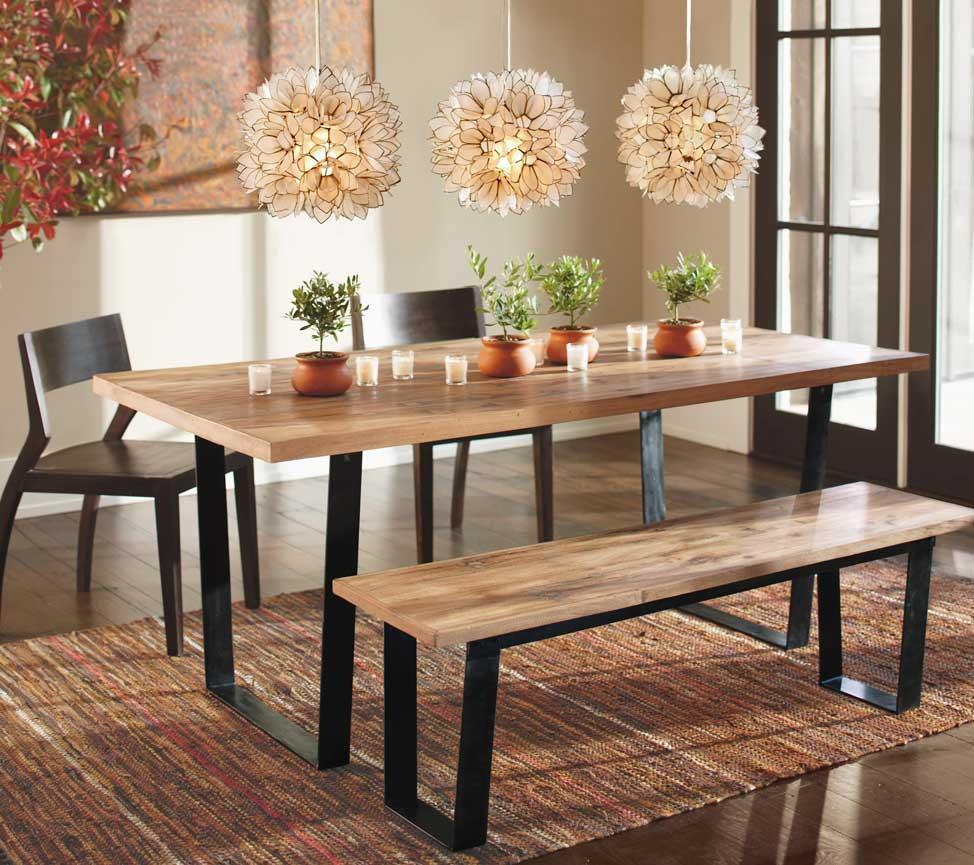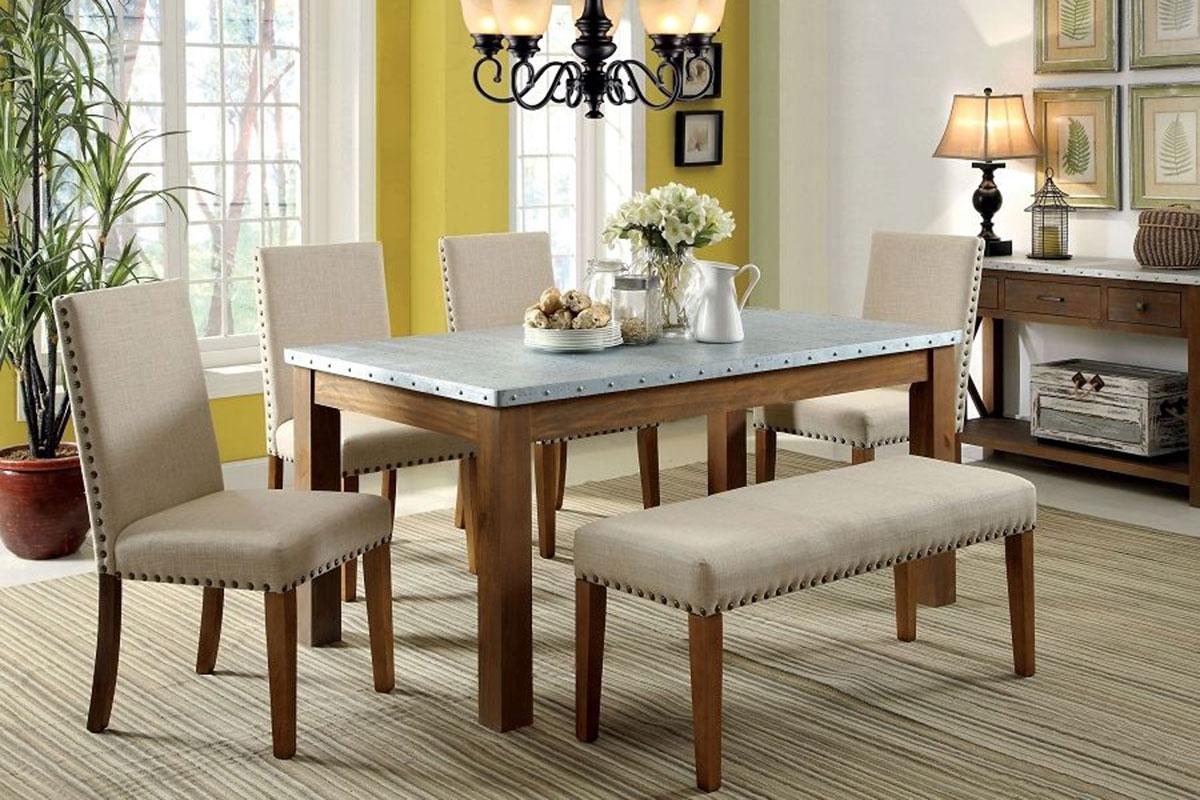The first image is the image on the left, the second image is the image on the right. Analyze the images presented: Is the assertion "there is a wooden dining table with a bench as one of the seats with 3 pendent lights above the table" valid? Answer yes or no. Yes. The first image is the image on the left, the second image is the image on the right. Considering the images on both sides, is "A rectangular table has high-backed armless white chairs along the far side and a bench along the side nearest to the camera." valid? Answer yes or no. Yes. 